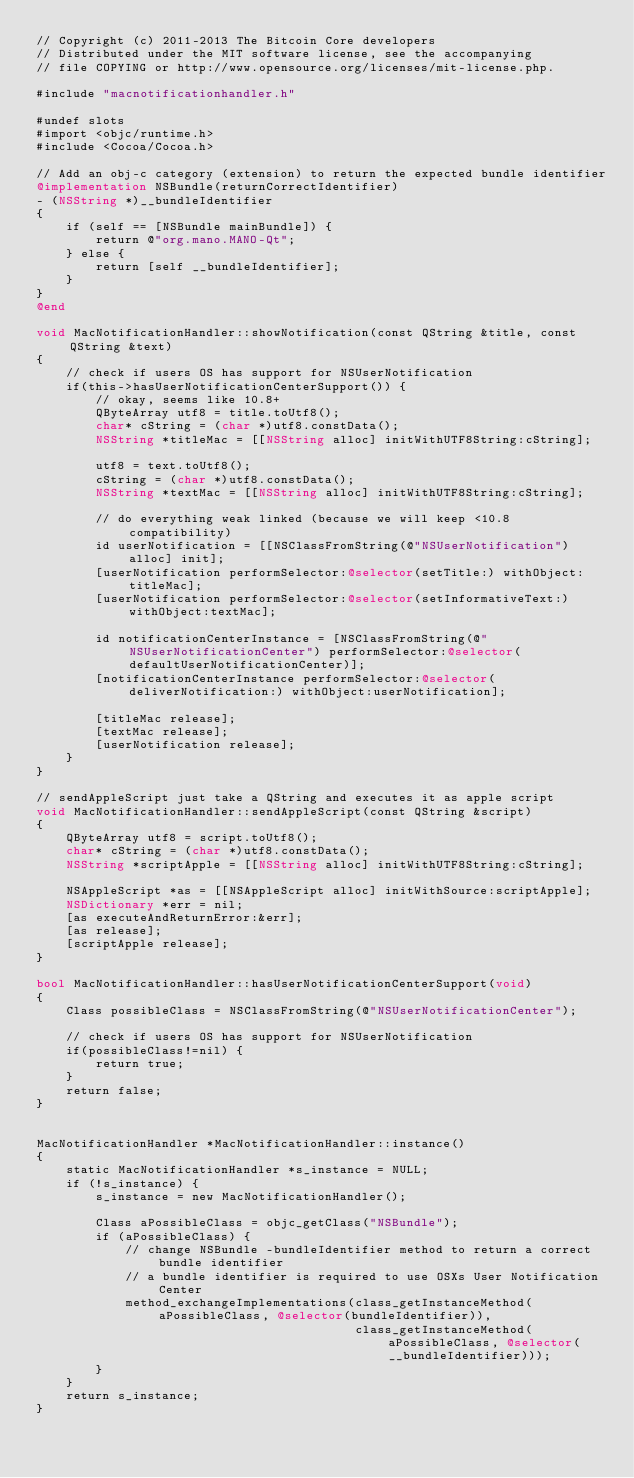<code> <loc_0><loc_0><loc_500><loc_500><_ObjectiveC_>// Copyright (c) 2011-2013 The Bitcoin Core developers
// Distributed under the MIT software license, see the accompanying
// file COPYING or http://www.opensource.org/licenses/mit-license.php.

#include "macnotificationhandler.h"

#undef slots
#import <objc/runtime.h>
#include <Cocoa/Cocoa.h>

// Add an obj-c category (extension) to return the expected bundle identifier
@implementation NSBundle(returnCorrectIdentifier)
- (NSString *)__bundleIdentifier
{
    if (self == [NSBundle mainBundle]) {
        return @"org.mano.MANO-Qt";
    } else {
        return [self __bundleIdentifier];
    }
}
@end

void MacNotificationHandler::showNotification(const QString &title, const QString &text)
{
    // check if users OS has support for NSUserNotification
    if(this->hasUserNotificationCenterSupport()) {
        // okay, seems like 10.8+
        QByteArray utf8 = title.toUtf8();
        char* cString = (char *)utf8.constData();
        NSString *titleMac = [[NSString alloc] initWithUTF8String:cString];

        utf8 = text.toUtf8();
        cString = (char *)utf8.constData();
        NSString *textMac = [[NSString alloc] initWithUTF8String:cString];

        // do everything weak linked (because we will keep <10.8 compatibility)
        id userNotification = [[NSClassFromString(@"NSUserNotification") alloc] init];
        [userNotification performSelector:@selector(setTitle:) withObject:titleMac];
        [userNotification performSelector:@selector(setInformativeText:) withObject:textMac];

        id notificationCenterInstance = [NSClassFromString(@"NSUserNotificationCenter") performSelector:@selector(defaultUserNotificationCenter)];
        [notificationCenterInstance performSelector:@selector(deliverNotification:) withObject:userNotification];

        [titleMac release];
        [textMac release];
        [userNotification release];
    }
}

// sendAppleScript just take a QString and executes it as apple script
void MacNotificationHandler::sendAppleScript(const QString &script)
{
    QByteArray utf8 = script.toUtf8();
    char* cString = (char *)utf8.constData();
    NSString *scriptApple = [[NSString alloc] initWithUTF8String:cString];

    NSAppleScript *as = [[NSAppleScript alloc] initWithSource:scriptApple];
    NSDictionary *err = nil;
    [as executeAndReturnError:&err];
    [as release];
    [scriptApple release];
}

bool MacNotificationHandler::hasUserNotificationCenterSupport(void)
{
    Class possibleClass = NSClassFromString(@"NSUserNotificationCenter");

    // check if users OS has support for NSUserNotification
    if(possibleClass!=nil) {
        return true;
    }
    return false;
}


MacNotificationHandler *MacNotificationHandler::instance()
{
    static MacNotificationHandler *s_instance = NULL;
    if (!s_instance) {
        s_instance = new MacNotificationHandler();
        
        Class aPossibleClass = objc_getClass("NSBundle");
        if (aPossibleClass) {
            // change NSBundle -bundleIdentifier method to return a correct bundle identifier
            // a bundle identifier is required to use OSXs User Notification Center
            method_exchangeImplementations(class_getInstanceMethod(aPossibleClass, @selector(bundleIdentifier)),
                                           class_getInstanceMethod(aPossibleClass, @selector(__bundleIdentifier)));
        }
    }
    return s_instance;
}
</code> 